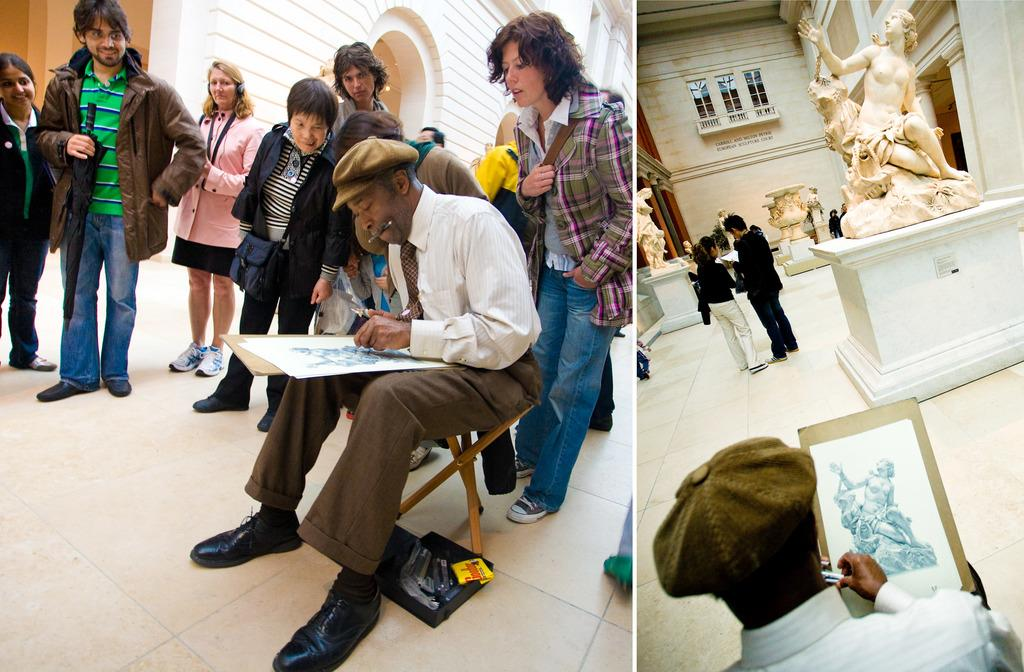How many people are present in the image? There are many people in the image. What type of image is this? The image is a collage. Can you describe what one person is doing in the image? There is a man sketching a statue in the image. What kind of setting is depicted in the image? The image appears to be set in a museum. What is visible beneath the people and objects in the image? There is a floor visible in the image. What type of canvas is the man using to sketch the statue? There is no canvas present in the image; the man is sketching the statue directly on paper or another surface. What is the occasion for the people celebrating in the image? There is no indication of a celebration or birthday in the image; it is set in a museum with people observing and interacting with various exhibits. 